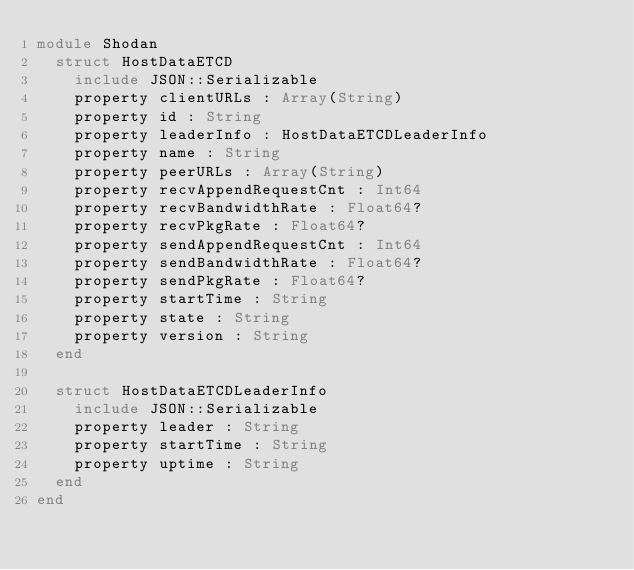<code> <loc_0><loc_0><loc_500><loc_500><_Crystal_>module Shodan
  struct HostDataETCD
    include JSON::Serializable
    property clientURLs : Array(String)
    property id : String
    property leaderInfo : HostDataETCDLeaderInfo
    property name : String
    property peerURLs : Array(String)
    property recvAppendRequestCnt : Int64
    property recvBandwidthRate : Float64?
    property recvPkgRate : Float64?
    property sendAppendRequestCnt : Int64
    property sendBandwidthRate : Float64?
    property sendPkgRate : Float64?
    property startTime : String
    property state : String
    property version : String
  end

  struct HostDataETCDLeaderInfo
    include JSON::Serializable
    property leader : String
    property startTime : String
    property uptime : String
  end
end
</code> 